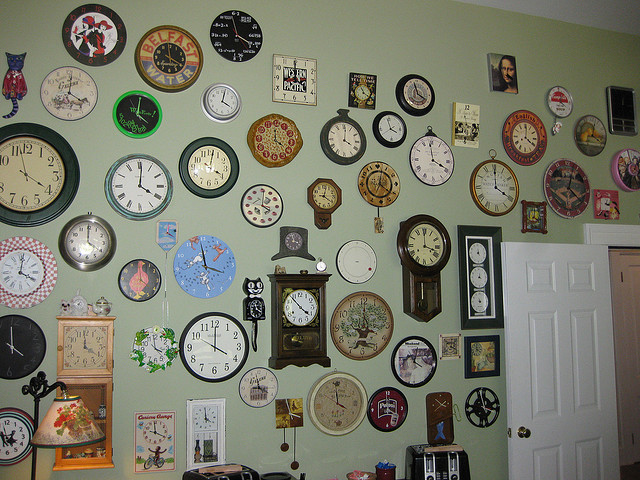How many cat clocks are there? There are two cat clocks, each featuring a unique and whimsical design, adding a playful touch to the collection. 